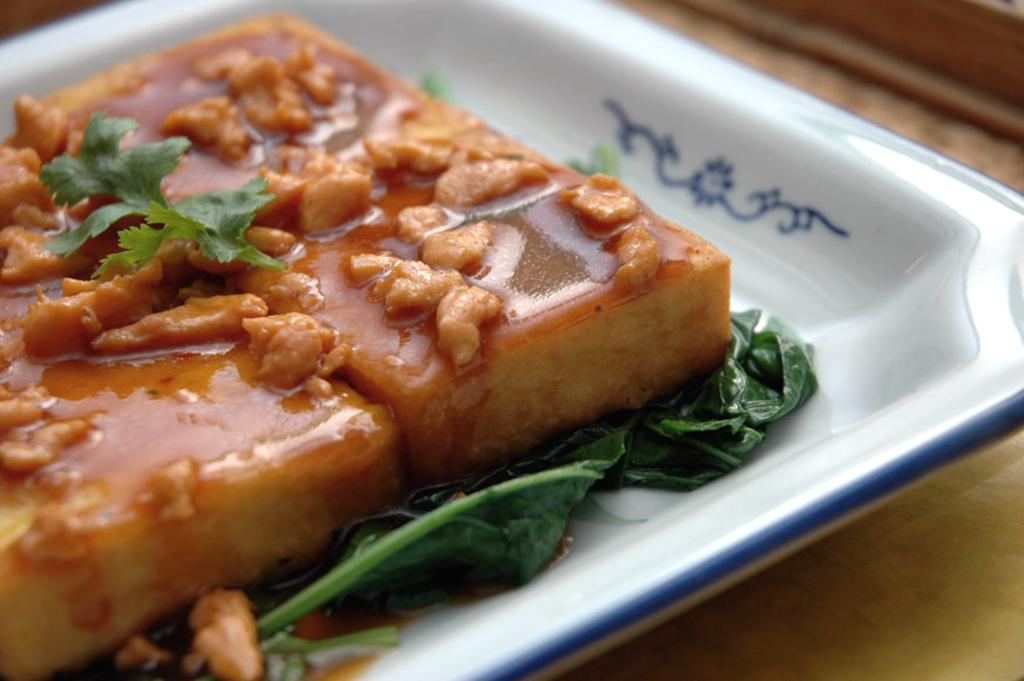What is on the plate that is visible in the image? There is a food item on a plate in the image. What is the plate placed on? The plate is placed on an object. Is there a stream of water flowing through the food item in the image? No, there is no stream of water flowing through the food item in the image. 